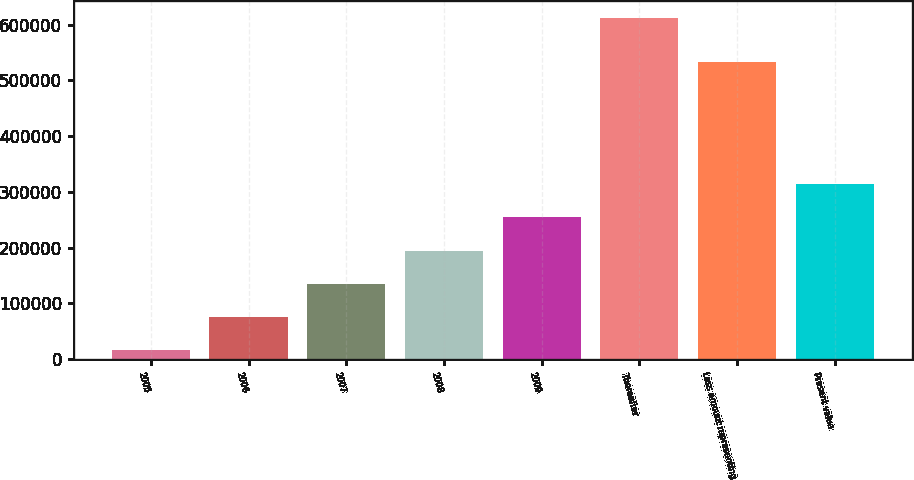<chart> <loc_0><loc_0><loc_500><loc_500><bar_chart><fcel>2005<fcel>2006<fcel>2007<fcel>2008<fcel>2009<fcel>Thereafter<fcel>Less amount representing<fcel>Present value<nl><fcel>15637<fcel>75335.9<fcel>135035<fcel>194734<fcel>254433<fcel>612626<fcel>533399<fcel>314132<nl></chart> 